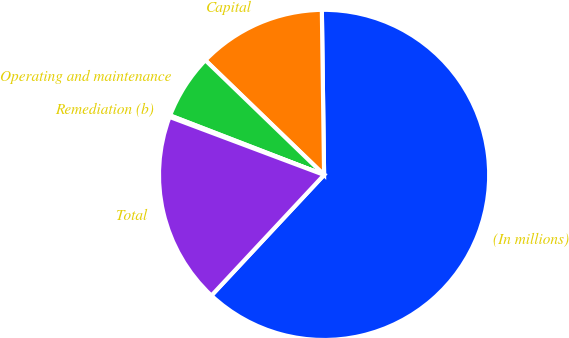Convert chart to OTSL. <chart><loc_0><loc_0><loc_500><loc_500><pie_chart><fcel>(In millions)<fcel>Capital<fcel>Operating and maintenance<fcel>Remediation (b)<fcel>Total<nl><fcel>62.17%<fcel>12.56%<fcel>6.36%<fcel>0.15%<fcel>18.76%<nl></chart> 